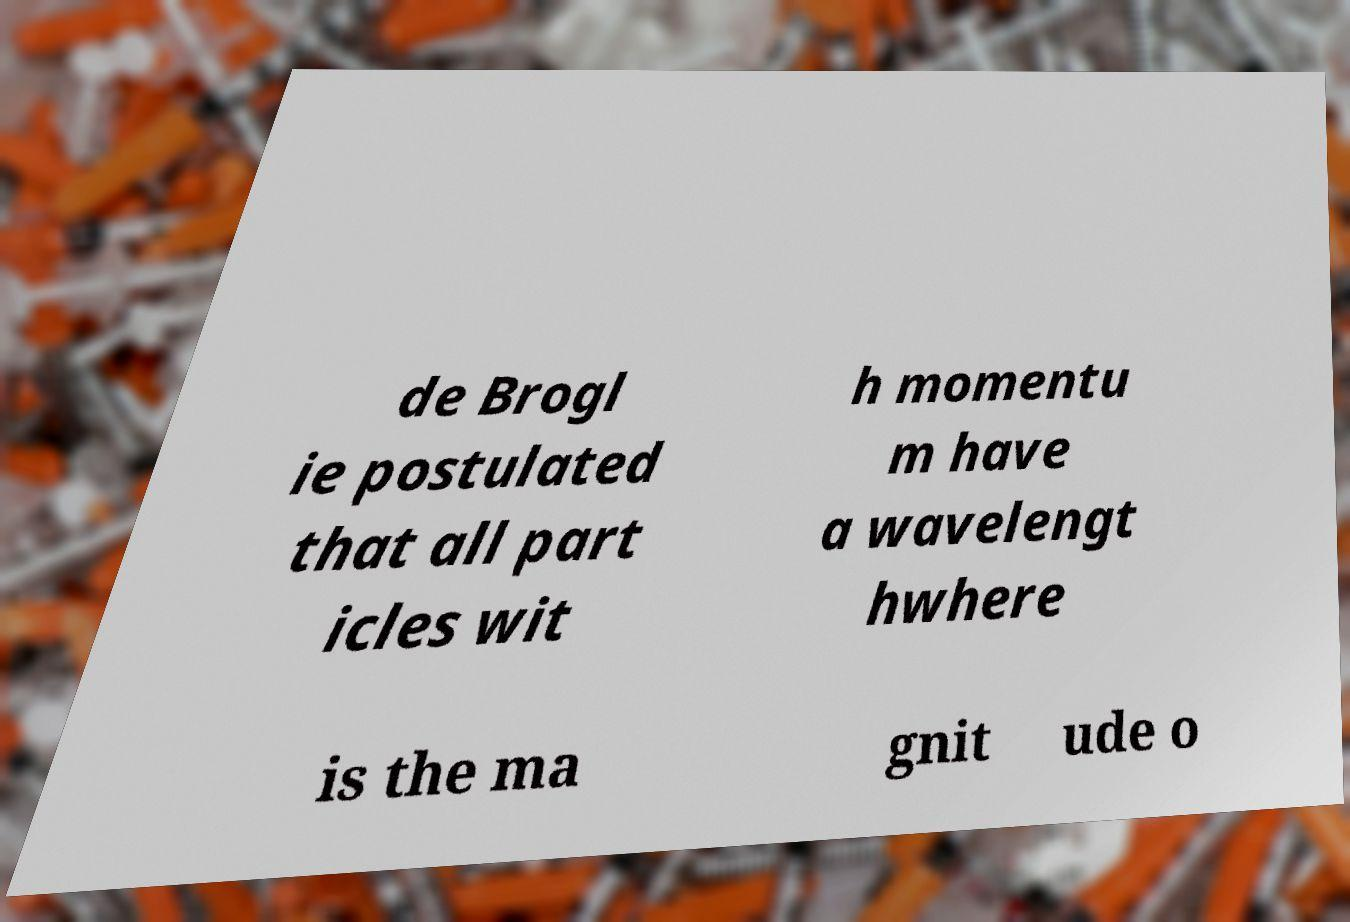There's text embedded in this image that I need extracted. Can you transcribe it verbatim? de Brogl ie postulated that all part icles wit h momentu m have a wavelengt hwhere is the ma gnit ude o 